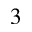<formula> <loc_0><loc_0><loc_500><loc_500>^ { 3 }</formula> 